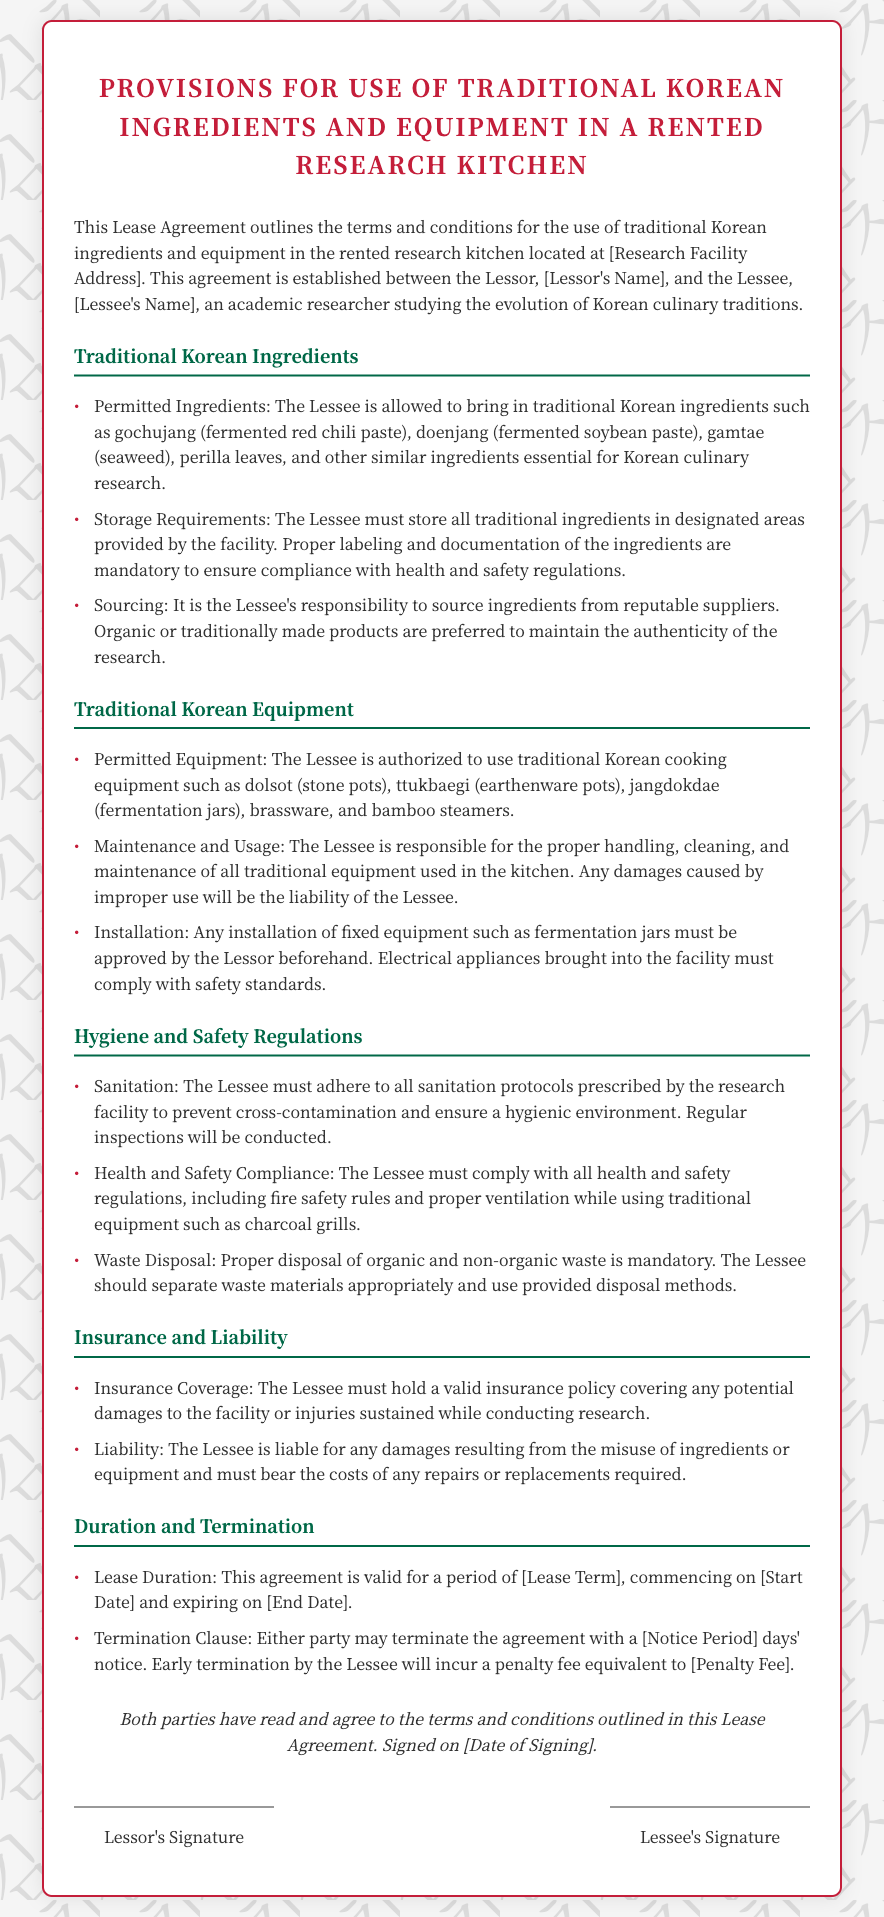what is the title of the document? The title is displayed prominently at the top of the agreement, indicating its purpose and content.
Answer: Provisions for Use of Traditional Korean Ingredients and Equipment in a Rented Research Kitchen who is the lesser in the agreement? The Lessor's name is specified within the document under the introductory description of the agreement.
Answer: [Lessor's Name] which traditional Korean ingredient is mentioned first? The first mentioned ingredient is highlighted in the list outlining permitted items.
Answer: gochujang what is the Lessee's responsibility regarding ingredients? This responsibility is outlined in a section that specifies the sourcing of ingredients in the agreement.
Answer: source ingredients from reputable suppliers how long is the lease agreement valid? The lease duration is specifically stated within the relevant section of the agreement as a time frame.
Answer: [Lease Term] what must the Lessee do with waste? The document details waste management responsibilities under the hygiene and safety regulations section.
Answer: separate waste materials appropriately how many days' notice is required for termination? The notice period for termination of the agreement is specified within the context of the termination clause.
Answer: [Notice Period] what type of equipment is specifically mentioned? The document lists types of equipment in the section dedicated to traditional Korean cooking tools.
Answer: dolsot what is the consequence of early termination by the Lessee? The document notes penalties specifically associated with the early termination of the lease agreement.
Answer: a penalty fee equivalent to [Penalty Fee] 